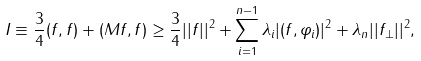Convert formula to latex. <formula><loc_0><loc_0><loc_500><loc_500>I \equiv \frac { 3 } { 4 } ( f , f ) + ( M f , f ) \geq \frac { 3 } { 4 } | | f | | ^ { 2 } + \sum _ { i = 1 } ^ { n - 1 } \lambda _ { i } | ( f , \varphi _ { i } ) | ^ { 2 } + \lambda _ { n } | | f _ { \perp } | | ^ { 2 } ,</formula> 